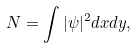Convert formula to latex. <formula><loc_0><loc_0><loc_500><loc_500>N = \int | \psi | ^ { 2 } d x d y ,</formula> 